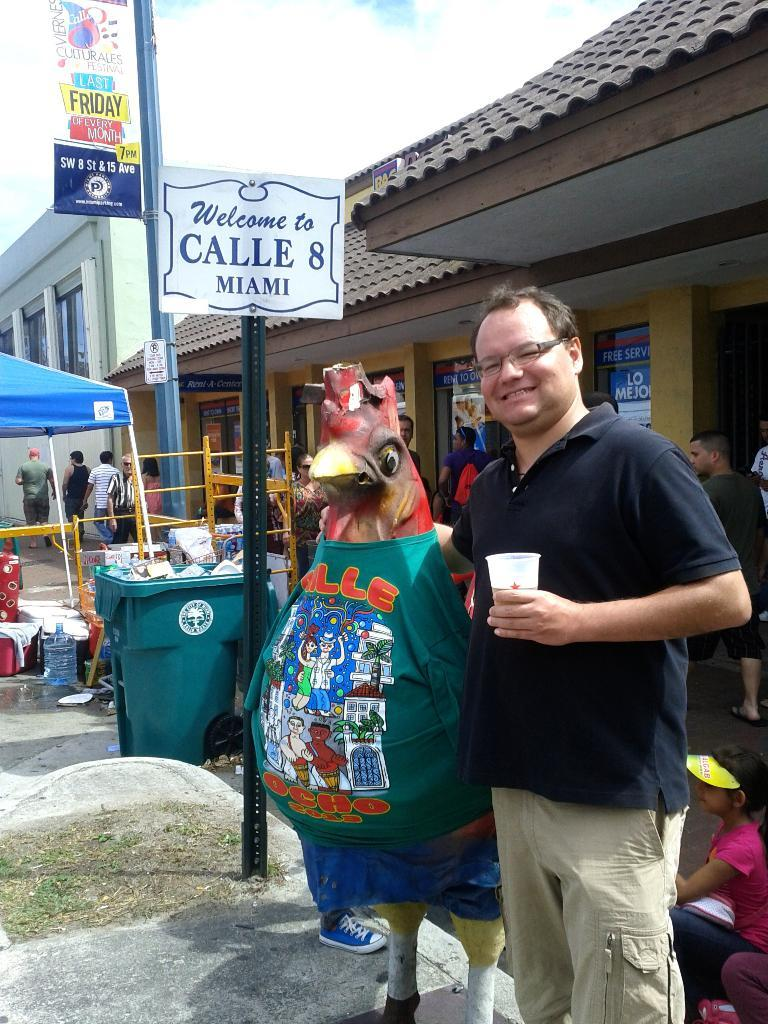<image>
Share a concise interpretation of the image provided. a chicken and a man standing in front of a sign that says 'welcome to calle 8 miami' 